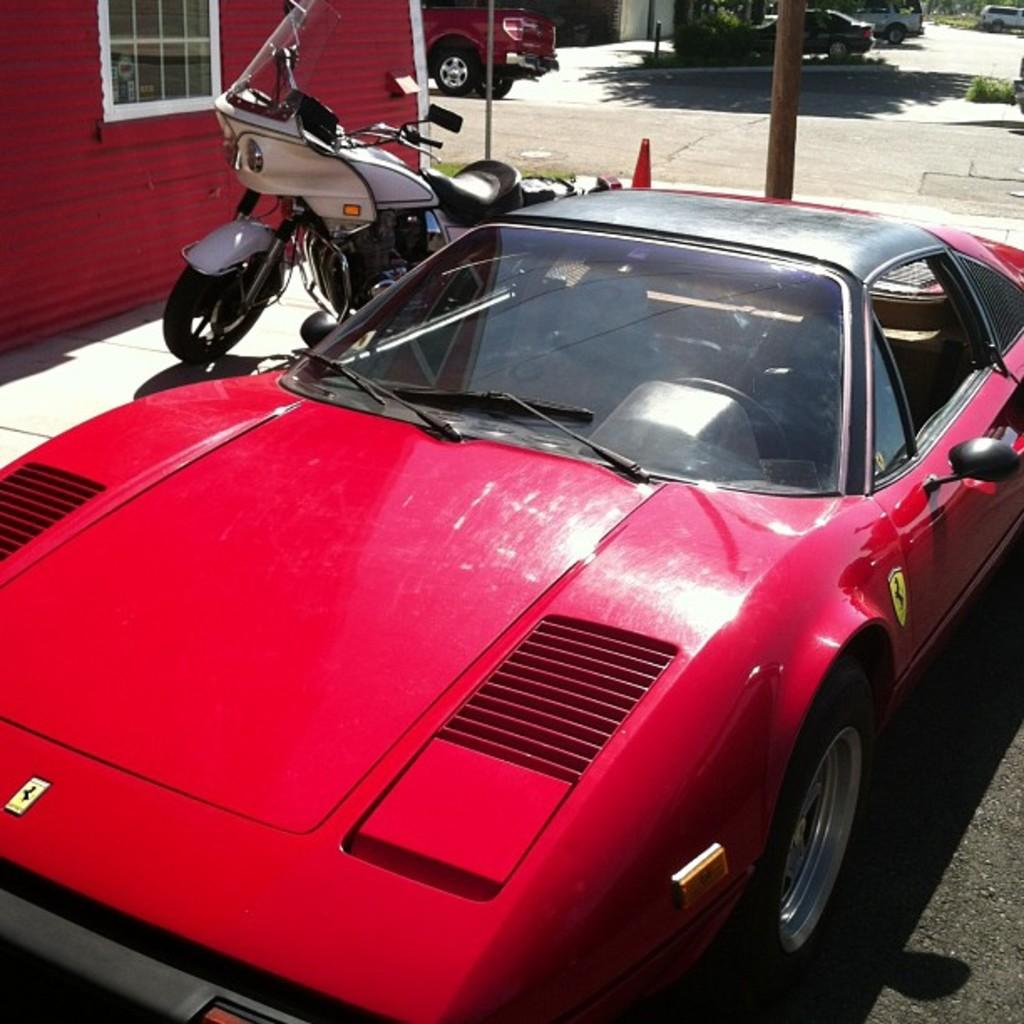What type of vehicle is visible in the image? There is a car and a bike in the image. Where are the car and bike located in relation to the building? The car and bike are parked in front of a building. What can be seen in the background of the image? There is a road in the background of the image. What is happening on the road? There is a vehicle on the road. What else can be seen on the road? There are trees on the road. What type of sound can be heard coming from the brass instrument in the image? There is no brass instrument present in the image, so it is not possible to determine what sound might be heard. 